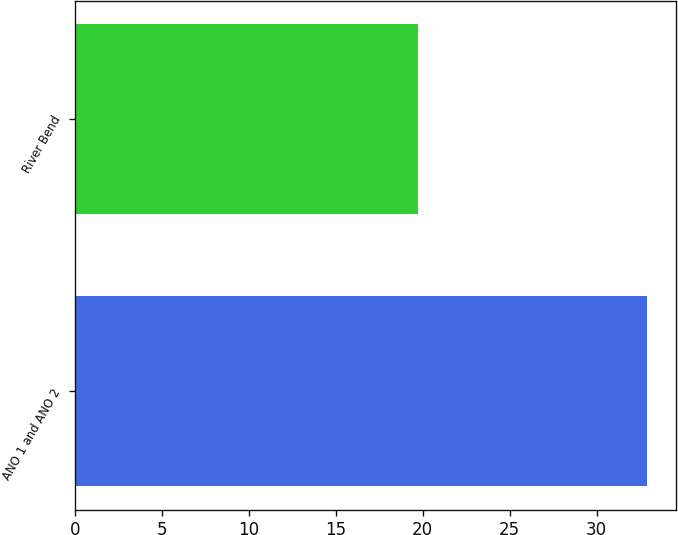Convert chart to OTSL. <chart><loc_0><loc_0><loc_500><loc_500><bar_chart><fcel>ANO 1 and ANO 2<fcel>River Bend<nl><fcel>32.9<fcel>19.7<nl></chart> 